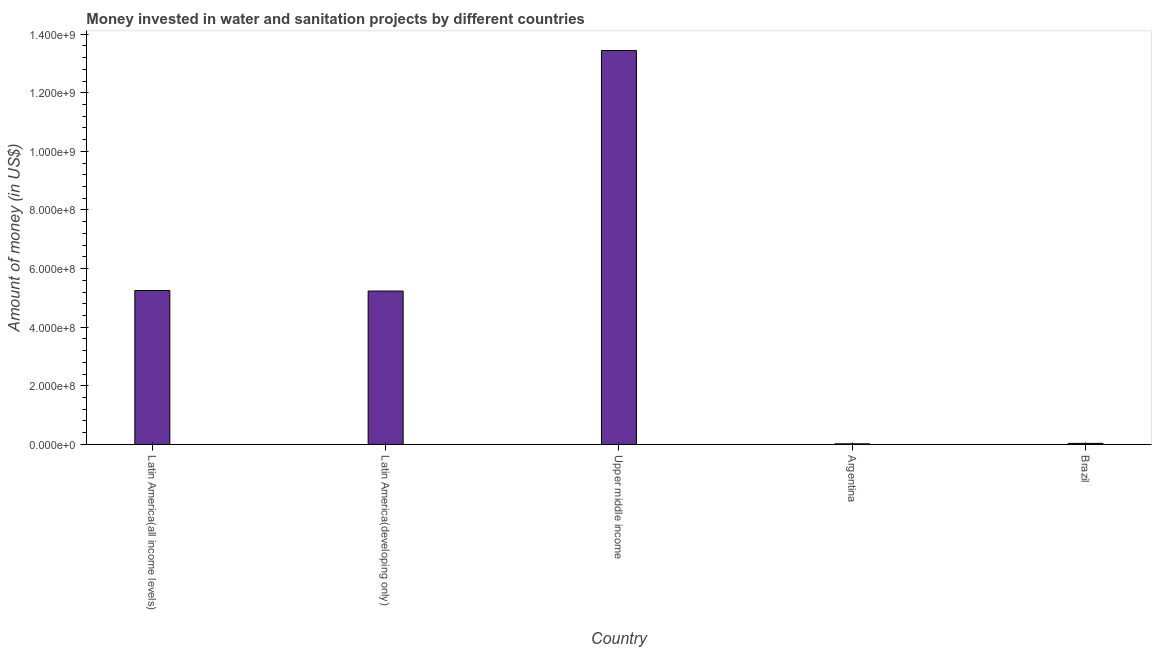Does the graph contain any zero values?
Your answer should be very brief. No. What is the title of the graph?
Give a very brief answer. Money invested in water and sanitation projects by different countries. What is the label or title of the X-axis?
Give a very brief answer. Country. What is the label or title of the Y-axis?
Ensure brevity in your answer.  Amount of money (in US$). What is the investment in Argentina?
Your answer should be compact. 1.90e+06. Across all countries, what is the maximum investment?
Provide a short and direct response. 1.34e+09. Across all countries, what is the minimum investment?
Give a very brief answer. 1.90e+06. In which country was the investment maximum?
Keep it short and to the point. Upper middle income. In which country was the investment minimum?
Your answer should be very brief. Argentina. What is the sum of the investment?
Provide a succinct answer. 2.40e+09. What is the difference between the investment in Brazil and Latin America(developing only)?
Give a very brief answer. -5.20e+08. What is the average investment per country?
Give a very brief answer. 4.80e+08. What is the median investment?
Your answer should be very brief. 5.23e+08. In how many countries, is the investment greater than 400000000 US$?
Offer a very short reply. 3. What is the ratio of the investment in Latin America(developing only) to that in Upper middle income?
Your answer should be very brief. 0.39. Is the difference between the investment in Brazil and Latin America(all income levels) greater than the difference between any two countries?
Provide a short and direct response. No. What is the difference between the highest and the second highest investment?
Your answer should be compact. 8.19e+08. What is the difference between the highest and the lowest investment?
Your response must be concise. 1.34e+09. In how many countries, is the investment greater than the average investment taken over all countries?
Your answer should be very brief. 3. How many bars are there?
Offer a terse response. 5. What is the Amount of money (in US$) in Latin America(all income levels)?
Give a very brief answer. 5.25e+08. What is the Amount of money (in US$) in Latin America(developing only)?
Provide a short and direct response. 5.23e+08. What is the Amount of money (in US$) of Upper middle income?
Your answer should be compact. 1.34e+09. What is the Amount of money (in US$) of Argentina?
Offer a terse response. 1.90e+06. What is the Amount of money (in US$) of Brazil?
Ensure brevity in your answer.  3.50e+06. What is the difference between the Amount of money (in US$) in Latin America(all income levels) and Latin America(developing only)?
Your answer should be compact. 1.90e+06. What is the difference between the Amount of money (in US$) in Latin America(all income levels) and Upper middle income?
Ensure brevity in your answer.  -8.19e+08. What is the difference between the Amount of money (in US$) in Latin America(all income levels) and Argentina?
Your answer should be very brief. 5.23e+08. What is the difference between the Amount of money (in US$) in Latin America(all income levels) and Brazil?
Ensure brevity in your answer.  5.22e+08. What is the difference between the Amount of money (in US$) in Latin America(developing only) and Upper middle income?
Your response must be concise. -8.21e+08. What is the difference between the Amount of money (in US$) in Latin America(developing only) and Argentina?
Provide a succinct answer. 5.21e+08. What is the difference between the Amount of money (in US$) in Latin America(developing only) and Brazil?
Provide a short and direct response. 5.20e+08. What is the difference between the Amount of money (in US$) in Upper middle income and Argentina?
Offer a terse response. 1.34e+09. What is the difference between the Amount of money (in US$) in Upper middle income and Brazil?
Make the answer very short. 1.34e+09. What is the difference between the Amount of money (in US$) in Argentina and Brazil?
Keep it short and to the point. -1.60e+06. What is the ratio of the Amount of money (in US$) in Latin America(all income levels) to that in Latin America(developing only)?
Your answer should be very brief. 1. What is the ratio of the Amount of money (in US$) in Latin America(all income levels) to that in Upper middle income?
Give a very brief answer. 0.39. What is the ratio of the Amount of money (in US$) in Latin America(all income levels) to that in Argentina?
Provide a succinct answer. 276.42. What is the ratio of the Amount of money (in US$) in Latin America(all income levels) to that in Brazil?
Give a very brief answer. 150.06. What is the ratio of the Amount of money (in US$) in Latin America(developing only) to that in Upper middle income?
Offer a very short reply. 0.39. What is the ratio of the Amount of money (in US$) in Latin America(developing only) to that in Argentina?
Keep it short and to the point. 275.42. What is the ratio of the Amount of money (in US$) in Latin America(developing only) to that in Brazil?
Keep it short and to the point. 149.51. What is the ratio of the Amount of money (in US$) in Upper middle income to that in Argentina?
Ensure brevity in your answer.  707.42. What is the ratio of the Amount of money (in US$) in Upper middle income to that in Brazil?
Provide a succinct answer. 384.03. What is the ratio of the Amount of money (in US$) in Argentina to that in Brazil?
Provide a short and direct response. 0.54. 